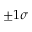<formula> <loc_0><loc_0><loc_500><loc_500>\pm 1 \sigma</formula> 